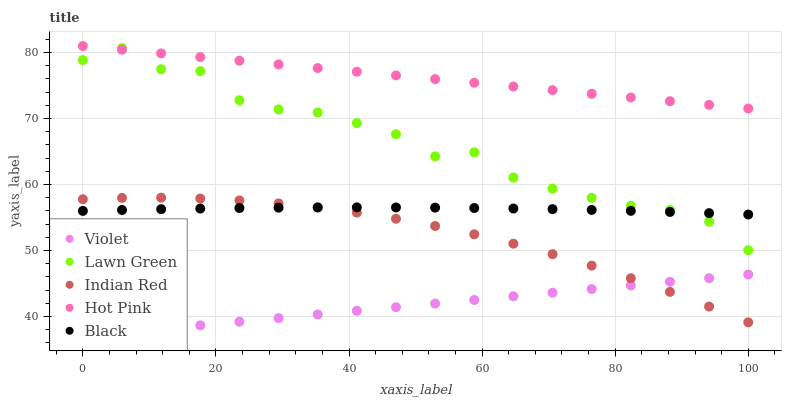Does Violet have the minimum area under the curve?
Answer yes or no. Yes. Does Hot Pink have the maximum area under the curve?
Answer yes or no. Yes. Does Black have the minimum area under the curve?
Answer yes or no. No. Does Black have the maximum area under the curve?
Answer yes or no. No. Is Violet the smoothest?
Answer yes or no. Yes. Is Lawn Green the roughest?
Answer yes or no. Yes. Is Hot Pink the smoothest?
Answer yes or no. No. Is Hot Pink the roughest?
Answer yes or no. No. Does Violet have the lowest value?
Answer yes or no. Yes. Does Black have the lowest value?
Answer yes or no. No. Does Hot Pink have the highest value?
Answer yes or no. Yes. Does Black have the highest value?
Answer yes or no. No. Is Violet less than Lawn Green?
Answer yes or no. Yes. Is Black greater than Violet?
Answer yes or no. Yes. Does Lawn Green intersect Hot Pink?
Answer yes or no. Yes. Is Lawn Green less than Hot Pink?
Answer yes or no. No. Is Lawn Green greater than Hot Pink?
Answer yes or no. No. Does Violet intersect Lawn Green?
Answer yes or no. No. 